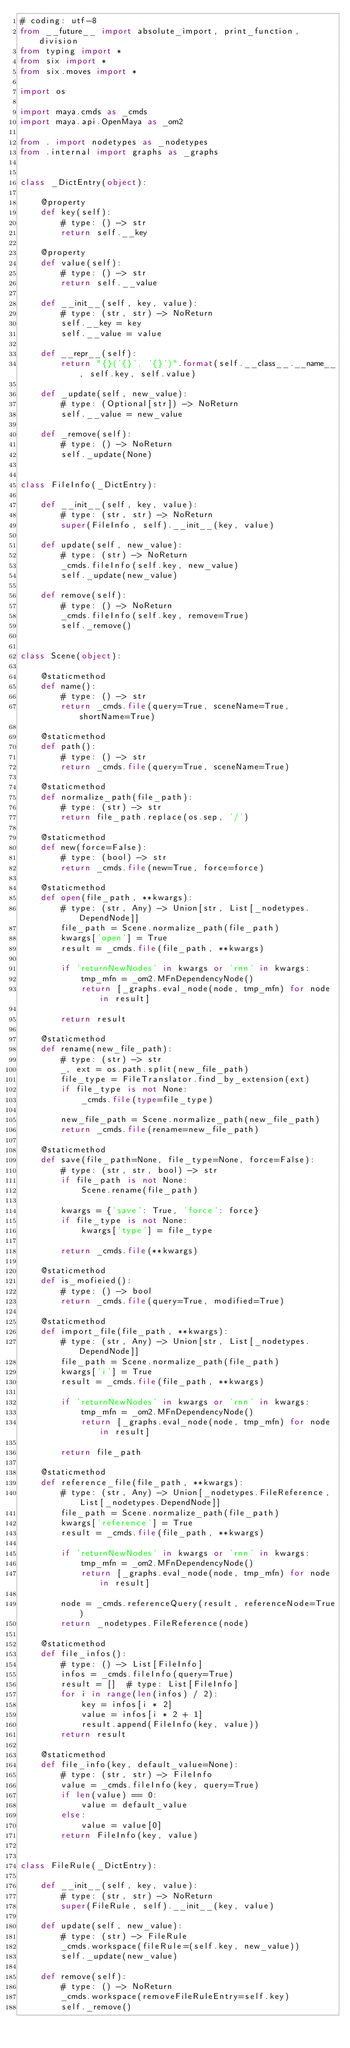Convert code to text. <code><loc_0><loc_0><loc_500><loc_500><_Python_># coding: utf-8
from __future__ import absolute_import, print_function, division
from typing import *
from six import *
from six.moves import *

import os

import maya.cmds as _cmds
import maya.api.OpenMaya as _om2

from . import nodetypes as _nodetypes
from .internal import graphs as _graphs


class _DictEntry(object):

    @property
    def key(self):
        # type: () -> str
        return self.__key

    @property
    def value(self):
        # type: () -> str
        return self.__value

    def __init__(self, key, value):
        # type: (str, str) -> NoReturn
        self.__key = key
        self.__value = value

    def __repr__(self):
        return "{}('{}', '{}')".format(self.__class__.__name__, self.key, self.value)

    def _update(self, new_value):
        # type: (Optional[str]) -> NoReturn
        self.__value = new_value

    def _remove(self):
        # type: () -> NoReturn
        self._update(None)


class FileInfo(_DictEntry):

    def __init__(self, key, value):
        # type: (str, str) -> NoReturn
        super(FileInfo, self).__init__(key, value)

    def update(self, new_value):
        # type: (str) -> NoReturn
        _cmds.fileInfo(self.key, new_value)
        self._update(new_value)

    def remove(self):
        # type: () -> NoReturn
        _cmds.fileInfo(self.key, remove=True)
        self._remove()


class Scene(object):

    @staticmethod
    def name():
        # type: () -> str
        return _cmds.file(query=True, sceneName=True, shortName=True)

    @staticmethod
    def path():
        # type: () -> str
        return _cmds.file(query=True, sceneName=True)

    @staticmethod
    def normalize_path(file_path):
        # type: (str) -> str
        return file_path.replace(os.sep, '/')

    @staticmethod
    def new(force=False):
        # type: (bool) -> str
        return _cmds.file(new=True, force=force)

    @staticmethod
    def open(file_path, **kwargs):
        # type: (str, Any) -> Union[str, List[_nodetypes.DependNode]]
        file_path = Scene.normalize_path(file_path)
        kwargs['open'] = True
        result = _cmds.file(file_path, **kwargs)

        if 'returnNewNodes' in kwargs or 'rnn' in kwargs:
            tmp_mfn = _om2.MFnDependencyNode()
            return [_graphs.eval_node(node, tmp_mfn) for node in result]

        return result

    @staticmethod
    def rename(new_file_path):
        # type: (str) -> str
        _, ext = os.path.split(new_file_path)
        file_type = FileTranslator.find_by_extension(ext)
        if file_type is not None:
            _cmds.file(type=file_type)

        new_file_path = Scene.normalize_path(new_file_path)
        return _cmds.file(rename=new_file_path)

    @staticmethod
    def save(file_path=None, file_type=None, force=False):
        # type: (str, str, bool) -> str
        if file_path is not None:
            Scene.rename(file_path)

        kwargs = {'save': True, 'force': force}
        if file_type is not None:
            kwargs['type'] = file_type

        return _cmds.file(**kwargs)

    @staticmethod
    def is_mofieied():
        # type: () -> bool
        return _cmds.file(query=True, modified=True)

    @staticmethod
    def import_file(file_path, **kwargs):
        # type: (str, Any) -> Union[str, List[_nodetypes.DependNode]]
        file_path = Scene.normalize_path(file_path)
        kwargs['i'] = True
        result = _cmds.file(file_path, **kwargs)

        if 'returnNewNodes' in kwargs or 'rnn' in kwargs:
            tmp_mfn = _om2.MFnDependencyNode()
            return [_graphs.eval_node(node, tmp_mfn) for node in result]

        return file_path

    @staticmethod
    def reference_file(file_path, **kwargs):
        # type: (str, Any) -> Union[_nodetypes.FileReference, List[_nodetypes.DependNode]]
        file_path = Scene.normalize_path(file_path)
        kwargs['reference'] = True
        result = _cmds.file(file_path, **kwargs)

        if 'returnNewNodes' in kwargs or 'rnn' in kwargs:
            tmp_mfn = _om2.MFnDependencyNode()
            return [_graphs.eval_node(node, tmp_mfn) for node in result]

        node = _cmds.referenceQuery(result, referenceNode=True)
        return _nodetypes.FileReference(node)

    @staticmethod
    def file_infos():
        # type: () -> List[FileInfo]
        infos = _cmds.fileInfo(query=True)
        result = []  # type: List[FileInfo]
        for i in range(len(infos) / 2):
            key = infos[i * 2]
            value = infos[i * 2 + 1]
            result.append(FileInfo(key, value))
        return result

    @staticmethod
    def file_info(key, default_value=None):
        # type: (str, str) -> FileInfo
        value = _cmds.fileInfo(key, query=True)
        if len(value) == 0:
            value = default_value
        else:
            value = value[0]
        return FileInfo(key, value)


class FileRule(_DictEntry):

    def __init__(self, key, value):
        # type: (str, str) -> NoReturn
        super(FileRule, self).__init__(key, value)

    def update(self, new_value):
        # type: (str) -> FileRule
        _cmds.workspace(fileRule=(self.key, new_value))
        self._update(new_value)

    def remove(self):
        # type: () -> NoReturn
        _cmds.workspace(removeFileRuleEntry=self.key)
        self._remove()

</code> 